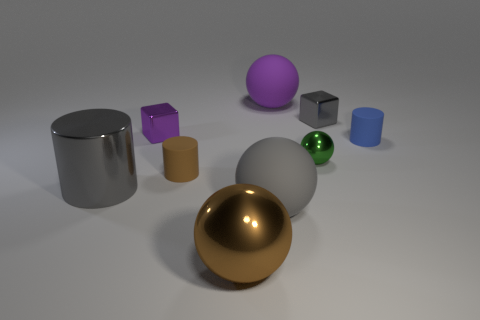Is there any other thing that is the same color as the small sphere?
Ensure brevity in your answer.  No. The tiny cylinder that is in front of the tiny rubber cylinder that is on the right side of the big brown thing is made of what material?
Offer a terse response. Rubber. There is a matte ball that is behind the small brown rubber object on the left side of the large matte sphere left of the purple matte object; how big is it?
Provide a short and direct response. Large. How many brown spheres have the same material as the gray block?
Make the answer very short. 1. There is a metal ball on the right side of the sphere that is behind the small blue rubber cylinder; what color is it?
Offer a very short reply. Green. What number of things are tiny rubber cylinders or small objects that are to the right of the brown sphere?
Give a very brief answer. 4. Are there any big rubber spheres that have the same color as the large shiny cylinder?
Offer a very short reply. Yes. How many blue things are large matte objects or tiny things?
Keep it short and to the point. 1. What number of other objects are there of the same size as the brown rubber cylinder?
Make the answer very short. 4. How many small things are purple shiny cubes or matte blocks?
Your answer should be very brief. 1. 